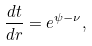<formula> <loc_0><loc_0><loc_500><loc_500>\frac { d t } { d r } = e ^ { \psi - \nu } ,</formula> 